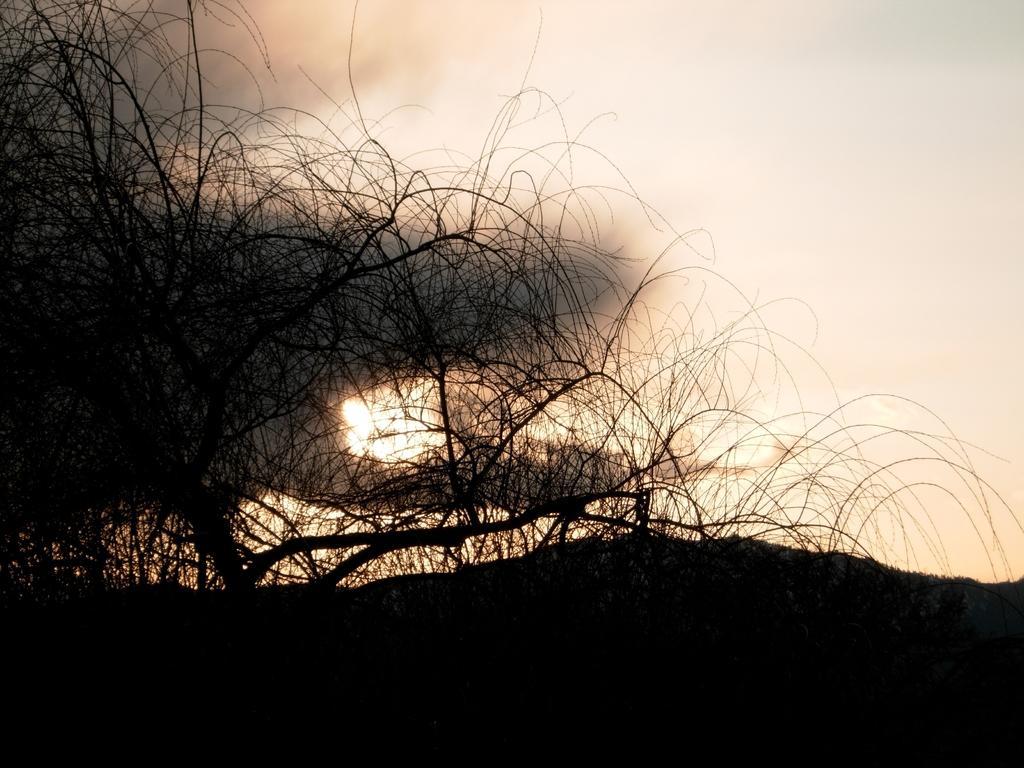In one or two sentences, can you explain what this image depicts? At the bottom the image is dark. On the left side we can see a bare tree. In the background we can see a smoke and sun in the sky. 